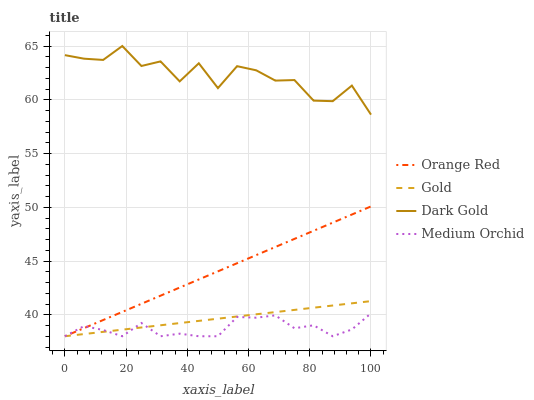Does Medium Orchid have the minimum area under the curve?
Answer yes or no. Yes. Does Dark Gold have the maximum area under the curve?
Answer yes or no. Yes. Does Orange Red have the minimum area under the curve?
Answer yes or no. No. Does Orange Red have the maximum area under the curve?
Answer yes or no. No. Is Gold the smoothest?
Answer yes or no. Yes. Is Dark Gold the roughest?
Answer yes or no. Yes. Is Orange Red the smoothest?
Answer yes or no. No. Is Orange Red the roughest?
Answer yes or no. No. Does Medium Orchid have the lowest value?
Answer yes or no. Yes. Does Dark Gold have the lowest value?
Answer yes or no. No. Does Dark Gold have the highest value?
Answer yes or no. Yes. Does Orange Red have the highest value?
Answer yes or no. No. Is Orange Red less than Dark Gold?
Answer yes or no. Yes. Is Dark Gold greater than Medium Orchid?
Answer yes or no. Yes. Does Medium Orchid intersect Orange Red?
Answer yes or no. Yes. Is Medium Orchid less than Orange Red?
Answer yes or no. No. Is Medium Orchid greater than Orange Red?
Answer yes or no. No. Does Orange Red intersect Dark Gold?
Answer yes or no. No. 